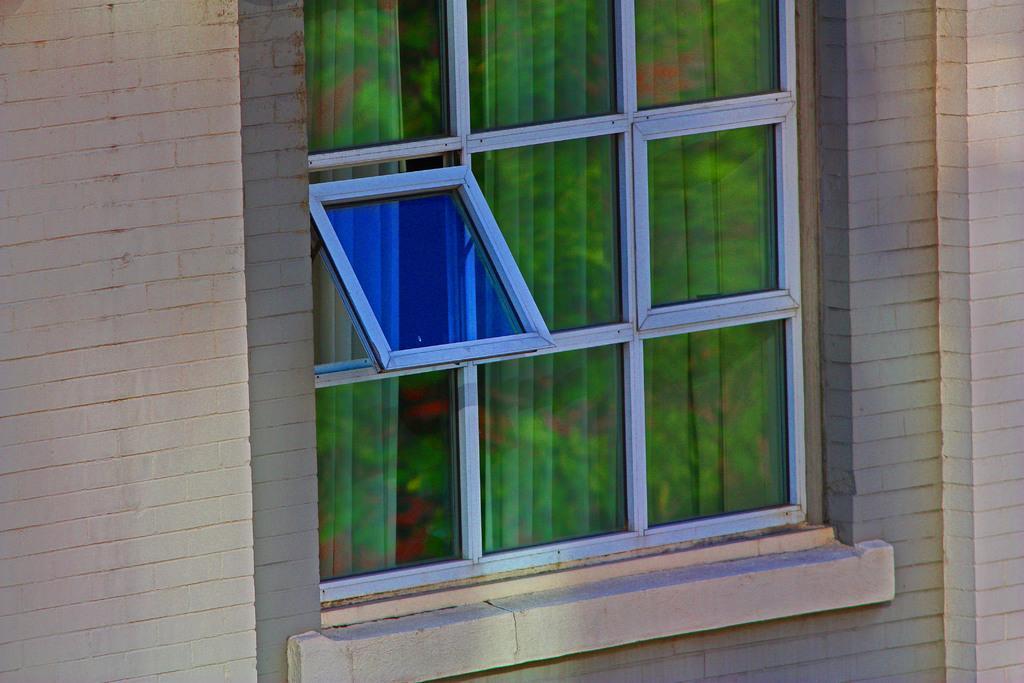Can you describe this image briefly? In this image we can see a wall and glass window with a curtain.  